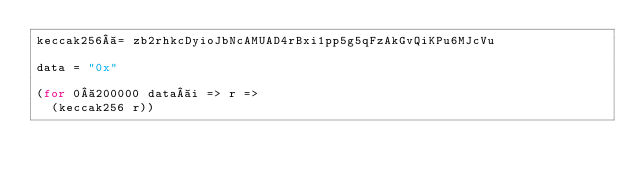<code> <loc_0><loc_0><loc_500><loc_500><_MoonScript_>keccak256 = zb2rhkcDyioJbNcAMUAD4rBxi1pp5g5qFzAkGvQiKPu6MJcVu

data = "0x"

(for 0 200000 data i => r =>
  (keccak256 r))
</code> 